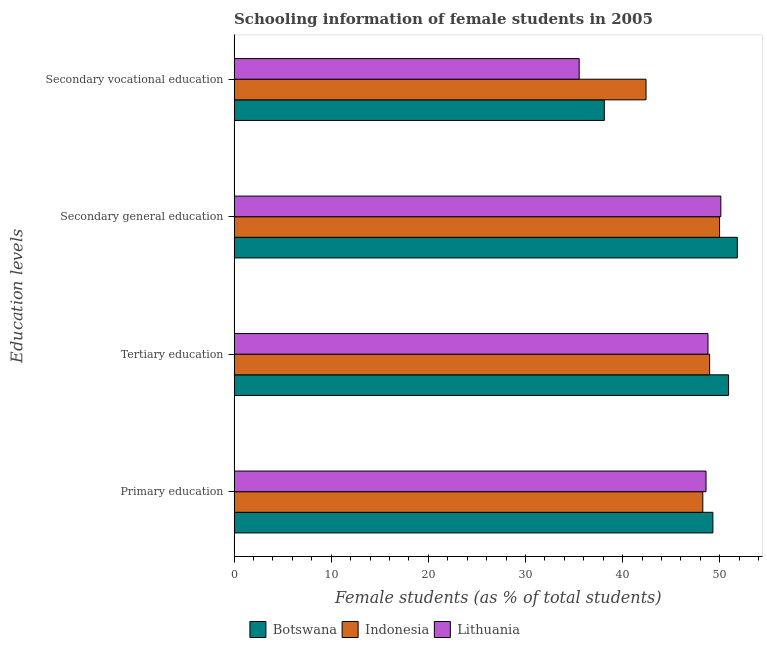How many groups of bars are there?
Provide a short and direct response. 4. How many bars are there on the 4th tick from the bottom?
Ensure brevity in your answer.  3. What is the label of the 1st group of bars from the top?
Make the answer very short. Secondary vocational education. What is the percentage of female students in tertiary education in Botswana?
Provide a short and direct response. 50.92. Across all countries, what is the maximum percentage of female students in tertiary education?
Ensure brevity in your answer.  50.92. Across all countries, what is the minimum percentage of female students in primary education?
Make the answer very short. 48.26. In which country was the percentage of female students in tertiary education maximum?
Provide a short and direct response. Botswana. In which country was the percentage of female students in secondary vocational education minimum?
Offer a very short reply. Lithuania. What is the total percentage of female students in primary education in the graph?
Offer a terse response. 146.15. What is the difference between the percentage of female students in secondary vocational education in Botswana and that in Indonesia?
Offer a very short reply. -4.3. What is the difference between the percentage of female students in secondary vocational education in Lithuania and the percentage of female students in primary education in Indonesia?
Ensure brevity in your answer.  -12.73. What is the average percentage of female students in tertiary education per country?
Offer a terse response. 49.56. What is the difference between the percentage of female students in secondary education and percentage of female students in secondary vocational education in Lithuania?
Your answer should be very brief. 14.59. What is the ratio of the percentage of female students in secondary vocational education in Lithuania to that in Botswana?
Give a very brief answer. 0.93. Is the difference between the percentage of female students in secondary education in Botswana and Lithuania greater than the difference between the percentage of female students in primary education in Botswana and Lithuania?
Give a very brief answer. Yes. What is the difference between the highest and the second highest percentage of female students in secondary vocational education?
Ensure brevity in your answer.  4.3. What is the difference between the highest and the lowest percentage of female students in primary education?
Keep it short and to the point. 1.04. Is the sum of the percentage of female students in secondary education in Lithuania and Indonesia greater than the maximum percentage of female students in primary education across all countries?
Keep it short and to the point. Yes. What does the 1st bar from the top in Secondary general education represents?
Give a very brief answer. Lithuania. What does the 3rd bar from the bottom in Secondary general education represents?
Your answer should be compact. Lithuania. Is it the case that in every country, the sum of the percentage of female students in primary education and percentage of female students in tertiary education is greater than the percentage of female students in secondary education?
Your answer should be compact. Yes. How many bars are there?
Keep it short and to the point. 12. How many countries are there in the graph?
Your response must be concise. 3. What is the difference between two consecutive major ticks on the X-axis?
Make the answer very short. 10. Are the values on the major ticks of X-axis written in scientific E-notation?
Offer a terse response. No. Does the graph contain any zero values?
Give a very brief answer. No. What is the title of the graph?
Keep it short and to the point. Schooling information of female students in 2005. Does "Eritrea" appear as one of the legend labels in the graph?
Provide a short and direct response. No. What is the label or title of the X-axis?
Offer a very short reply. Female students (as % of total students). What is the label or title of the Y-axis?
Your answer should be very brief. Education levels. What is the Female students (as % of total students) in Botswana in Primary education?
Provide a succinct answer. 49.3. What is the Female students (as % of total students) of Indonesia in Primary education?
Provide a short and direct response. 48.26. What is the Female students (as % of total students) of Lithuania in Primary education?
Your response must be concise. 48.59. What is the Female students (as % of total students) in Botswana in Tertiary education?
Keep it short and to the point. 50.92. What is the Female students (as % of total students) of Indonesia in Tertiary education?
Give a very brief answer. 48.96. What is the Female students (as % of total students) of Lithuania in Tertiary education?
Keep it short and to the point. 48.79. What is the Female students (as % of total students) of Botswana in Secondary general education?
Give a very brief answer. 51.82. What is the Female students (as % of total students) of Indonesia in Secondary general education?
Your response must be concise. 49.99. What is the Female students (as % of total students) of Lithuania in Secondary general education?
Make the answer very short. 50.12. What is the Female students (as % of total students) of Botswana in Secondary vocational education?
Ensure brevity in your answer.  38.12. What is the Female students (as % of total students) in Indonesia in Secondary vocational education?
Provide a short and direct response. 42.41. What is the Female students (as % of total students) of Lithuania in Secondary vocational education?
Provide a short and direct response. 35.53. Across all Education levels, what is the maximum Female students (as % of total students) of Botswana?
Your response must be concise. 51.82. Across all Education levels, what is the maximum Female students (as % of total students) in Indonesia?
Provide a short and direct response. 49.99. Across all Education levels, what is the maximum Female students (as % of total students) in Lithuania?
Make the answer very short. 50.12. Across all Education levels, what is the minimum Female students (as % of total students) of Botswana?
Give a very brief answer. 38.12. Across all Education levels, what is the minimum Female students (as % of total students) of Indonesia?
Your answer should be very brief. 42.41. Across all Education levels, what is the minimum Female students (as % of total students) of Lithuania?
Offer a terse response. 35.53. What is the total Female students (as % of total students) in Botswana in the graph?
Give a very brief answer. 190.15. What is the total Female students (as % of total students) of Indonesia in the graph?
Provide a succinct answer. 189.62. What is the total Female students (as % of total students) of Lithuania in the graph?
Offer a very short reply. 183.03. What is the difference between the Female students (as % of total students) of Botswana in Primary education and that in Tertiary education?
Provide a short and direct response. -1.62. What is the difference between the Female students (as % of total students) of Indonesia in Primary education and that in Tertiary education?
Ensure brevity in your answer.  -0.7. What is the difference between the Female students (as % of total students) of Lithuania in Primary education and that in Tertiary education?
Provide a succinct answer. -0.2. What is the difference between the Female students (as % of total students) in Botswana in Primary education and that in Secondary general education?
Offer a very short reply. -2.52. What is the difference between the Female students (as % of total students) of Indonesia in Primary education and that in Secondary general education?
Give a very brief answer. -1.73. What is the difference between the Female students (as % of total students) in Lithuania in Primary education and that in Secondary general education?
Offer a very short reply. -1.53. What is the difference between the Female students (as % of total students) in Botswana in Primary education and that in Secondary vocational education?
Ensure brevity in your answer.  11.18. What is the difference between the Female students (as % of total students) of Indonesia in Primary education and that in Secondary vocational education?
Provide a short and direct response. 5.85. What is the difference between the Female students (as % of total students) in Lithuania in Primary education and that in Secondary vocational education?
Offer a very short reply. 13.06. What is the difference between the Female students (as % of total students) of Botswana in Tertiary education and that in Secondary general education?
Your answer should be very brief. -0.9. What is the difference between the Female students (as % of total students) of Indonesia in Tertiary education and that in Secondary general education?
Provide a short and direct response. -1.02. What is the difference between the Female students (as % of total students) of Lithuania in Tertiary education and that in Secondary general education?
Make the answer very short. -1.32. What is the difference between the Female students (as % of total students) of Botswana in Tertiary education and that in Secondary vocational education?
Offer a terse response. 12.8. What is the difference between the Female students (as % of total students) of Indonesia in Tertiary education and that in Secondary vocational education?
Make the answer very short. 6.55. What is the difference between the Female students (as % of total students) of Lithuania in Tertiary education and that in Secondary vocational education?
Provide a short and direct response. 13.26. What is the difference between the Female students (as % of total students) in Botswana in Secondary general education and that in Secondary vocational education?
Your answer should be compact. 13.7. What is the difference between the Female students (as % of total students) of Indonesia in Secondary general education and that in Secondary vocational education?
Your answer should be compact. 7.57. What is the difference between the Female students (as % of total students) in Lithuania in Secondary general education and that in Secondary vocational education?
Offer a terse response. 14.59. What is the difference between the Female students (as % of total students) in Botswana in Primary education and the Female students (as % of total students) in Indonesia in Tertiary education?
Keep it short and to the point. 0.34. What is the difference between the Female students (as % of total students) in Botswana in Primary education and the Female students (as % of total students) in Lithuania in Tertiary education?
Your answer should be very brief. 0.51. What is the difference between the Female students (as % of total students) in Indonesia in Primary education and the Female students (as % of total students) in Lithuania in Tertiary education?
Provide a short and direct response. -0.53. What is the difference between the Female students (as % of total students) of Botswana in Primary education and the Female students (as % of total students) of Indonesia in Secondary general education?
Offer a terse response. -0.69. What is the difference between the Female students (as % of total students) of Botswana in Primary education and the Female students (as % of total students) of Lithuania in Secondary general education?
Make the answer very short. -0.82. What is the difference between the Female students (as % of total students) of Indonesia in Primary education and the Female students (as % of total students) of Lithuania in Secondary general education?
Your answer should be compact. -1.86. What is the difference between the Female students (as % of total students) in Botswana in Primary education and the Female students (as % of total students) in Indonesia in Secondary vocational education?
Provide a succinct answer. 6.88. What is the difference between the Female students (as % of total students) of Botswana in Primary education and the Female students (as % of total students) of Lithuania in Secondary vocational education?
Provide a short and direct response. 13.77. What is the difference between the Female students (as % of total students) of Indonesia in Primary education and the Female students (as % of total students) of Lithuania in Secondary vocational education?
Provide a short and direct response. 12.73. What is the difference between the Female students (as % of total students) of Botswana in Tertiary education and the Female students (as % of total students) of Indonesia in Secondary general education?
Offer a terse response. 0.93. What is the difference between the Female students (as % of total students) in Botswana in Tertiary education and the Female students (as % of total students) in Lithuania in Secondary general education?
Keep it short and to the point. 0.8. What is the difference between the Female students (as % of total students) in Indonesia in Tertiary education and the Female students (as % of total students) in Lithuania in Secondary general education?
Offer a very short reply. -1.16. What is the difference between the Female students (as % of total students) of Botswana in Tertiary education and the Female students (as % of total students) of Indonesia in Secondary vocational education?
Give a very brief answer. 8.5. What is the difference between the Female students (as % of total students) in Botswana in Tertiary education and the Female students (as % of total students) in Lithuania in Secondary vocational education?
Give a very brief answer. 15.38. What is the difference between the Female students (as % of total students) of Indonesia in Tertiary education and the Female students (as % of total students) of Lithuania in Secondary vocational education?
Offer a very short reply. 13.43. What is the difference between the Female students (as % of total students) of Botswana in Secondary general education and the Female students (as % of total students) of Indonesia in Secondary vocational education?
Keep it short and to the point. 9.4. What is the difference between the Female students (as % of total students) in Botswana in Secondary general education and the Female students (as % of total students) in Lithuania in Secondary vocational education?
Your response must be concise. 16.29. What is the difference between the Female students (as % of total students) of Indonesia in Secondary general education and the Female students (as % of total students) of Lithuania in Secondary vocational education?
Offer a terse response. 14.46. What is the average Female students (as % of total students) in Botswana per Education levels?
Give a very brief answer. 47.54. What is the average Female students (as % of total students) in Indonesia per Education levels?
Your answer should be compact. 47.41. What is the average Female students (as % of total students) in Lithuania per Education levels?
Keep it short and to the point. 45.76. What is the difference between the Female students (as % of total students) of Botswana and Female students (as % of total students) of Indonesia in Primary education?
Your response must be concise. 1.04. What is the difference between the Female students (as % of total students) in Botswana and Female students (as % of total students) in Lithuania in Primary education?
Provide a short and direct response. 0.71. What is the difference between the Female students (as % of total students) of Indonesia and Female students (as % of total students) of Lithuania in Primary education?
Give a very brief answer. -0.33. What is the difference between the Female students (as % of total students) of Botswana and Female students (as % of total students) of Indonesia in Tertiary education?
Your answer should be compact. 1.95. What is the difference between the Female students (as % of total students) in Botswana and Female students (as % of total students) in Lithuania in Tertiary education?
Make the answer very short. 2.12. What is the difference between the Female students (as % of total students) of Indonesia and Female students (as % of total students) of Lithuania in Tertiary education?
Your answer should be very brief. 0.17. What is the difference between the Female students (as % of total students) in Botswana and Female students (as % of total students) in Indonesia in Secondary general education?
Ensure brevity in your answer.  1.83. What is the difference between the Female students (as % of total students) of Botswana and Female students (as % of total students) of Lithuania in Secondary general education?
Ensure brevity in your answer.  1.7. What is the difference between the Female students (as % of total students) in Indonesia and Female students (as % of total students) in Lithuania in Secondary general education?
Your answer should be compact. -0.13. What is the difference between the Female students (as % of total students) in Botswana and Female students (as % of total students) in Indonesia in Secondary vocational education?
Your response must be concise. -4.3. What is the difference between the Female students (as % of total students) in Botswana and Female students (as % of total students) in Lithuania in Secondary vocational education?
Offer a very short reply. 2.59. What is the difference between the Female students (as % of total students) in Indonesia and Female students (as % of total students) in Lithuania in Secondary vocational education?
Offer a very short reply. 6.88. What is the ratio of the Female students (as % of total students) of Botswana in Primary education to that in Tertiary education?
Keep it short and to the point. 0.97. What is the ratio of the Female students (as % of total students) of Indonesia in Primary education to that in Tertiary education?
Make the answer very short. 0.99. What is the ratio of the Female students (as % of total students) in Botswana in Primary education to that in Secondary general education?
Your response must be concise. 0.95. What is the ratio of the Female students (as % of total students) in Indonesia in Primary education to that in Secondary general education?
Make the answer very short. 0.97. What is the ratio of the Female students (as % of total students) of Lithuania in Primary education to that in Secondary general education?
Your response must be concise. 0.97. What is the ratio of the Female students (as % of total students) of Botswana in Primary education to that in Secondary vocational education?
Provide a succinct answer. 1.29. What is the ratio of the Female students (as % of total students) in Indonesia in Primary education to that in Secondary vocational education?
Provide a succinct answer. 1.14. What is the ratio of the Female students (as % of total students) in Lithuania in Primary education to that in Secondary vocational education?
Your response must be concise. 1.37. What is the ratio of the Female students (as % of total students) of Botswana in Tertiary education to that in Secondary general education?
Offer a very short reply. 0.98. What is the ratio of the Female students (as % of total students) in Indonesia in Tertiary education to that in Secondary general education?
Your answer should be compact. 0.98. What is the ratio of the Female students (as % of total students) in Lithuania in Tertiary education to that in Secondary general education?
Your answer should be very brief. 0.97. What is the ratio of the Female students (as % of total students) of Botswana in Tertiary education to that in Secondary vocational education?
Provide a short and direct response. 1.34. What is the ratio of the Female students (as % of total students) of Indonesia in Tertiary education to that in Secondary vocational education?
Provide a succinct answer. 1.15. What is the ratio of the Female students (as % of total students) in Lithuania in Tertiary education to that in Secondary vocational education?
Your response must be concise. 1.37. What is the ratio of the Female students (as % of total students) in Botswana in Secondary general education to that in Secondary vocational education?
Offer a very short reply. 1.36. What is the ratio of the Female students (as % of total students) of Indonesia in Secondary general education to that in Secondary vocational education?
Offer a very short reply. 1.18. What is the ratio of the Female students (as % of total students) of Lithuania in Secondary general education to that in Secondary vocational education?
Give a very brief answer. 1.41. What is the difference between the highest and the second highest Female students (as % of total students) of Botswana?
Offer a terse response. 0.9. What is the difference between the highest and the second highest Female students (as % of total students) in Indonesia?
Ensure brevity in your answer.  1.02. What is the difference between the highest and the second highest Female students (as % of total students) of Lithuania?
Ensure brevity in your answer.  1.32. What is the difference between the highest and the lowest Female students (as % of total students) of Botswana?
Provide a short and direct response. 13.7. What is the difference between the highest and the lowest Female students (as % of total students) of Indonesia?
Make the answer very short. 7.57. What is the difference between the highest and the lowest Female students (as % of total students) of Lithuania?
Offer a terse response. 14.59. 